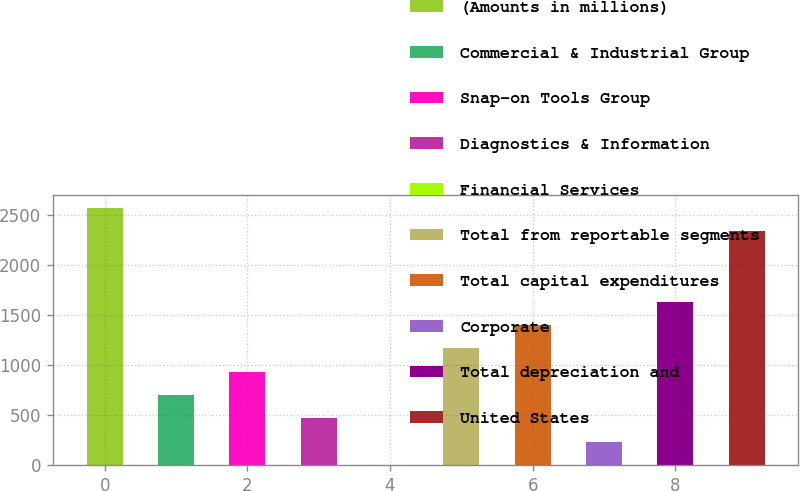Convert chart. <chart><loc_0><loc_0><loc_500><loc_500><bar_chart><fcel>(Amounts in millions)<fcel>Commercial & Industrial Group<fcel>Snap-on Tools Group<fcel>Diagnostics & Information<fcel>Financial Services<fcel>Total from reportable segments<fcel>Total capital expenditures<fcel>Corporate<fcel>Total depreciation and<fcel>United States<nl><fcel>2567.95<fcel>701.15<fcel>934.5<fcel>467.8<fcel>1.1<fcel>1167.85<fcel>1401.2<fcel>234.45<fcel>1634.55<fcel>2334.6<nl></chart> 